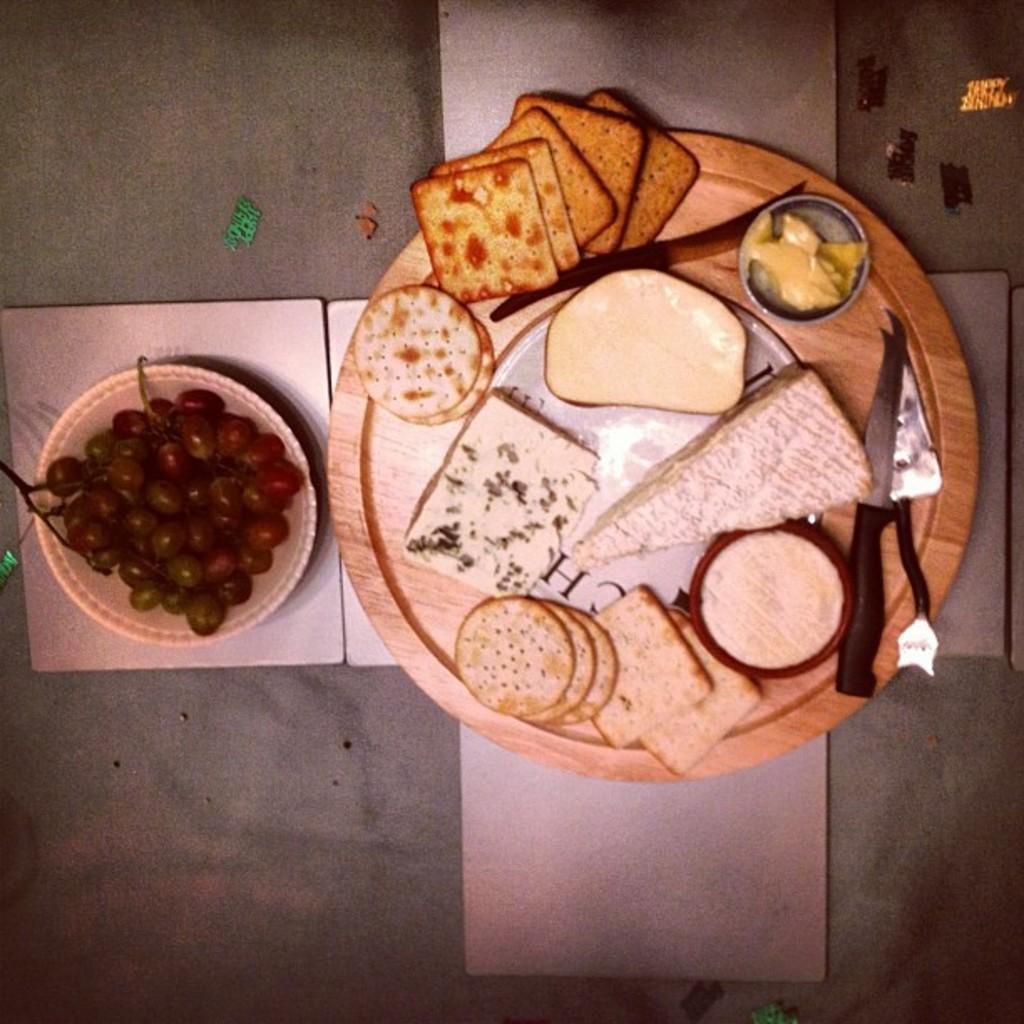How would you summarize this image in a sentence or two? In this picture we can see a plate with food items and a knife on it, bowl with grapes in it and some objects and these all are placed on a platform. 